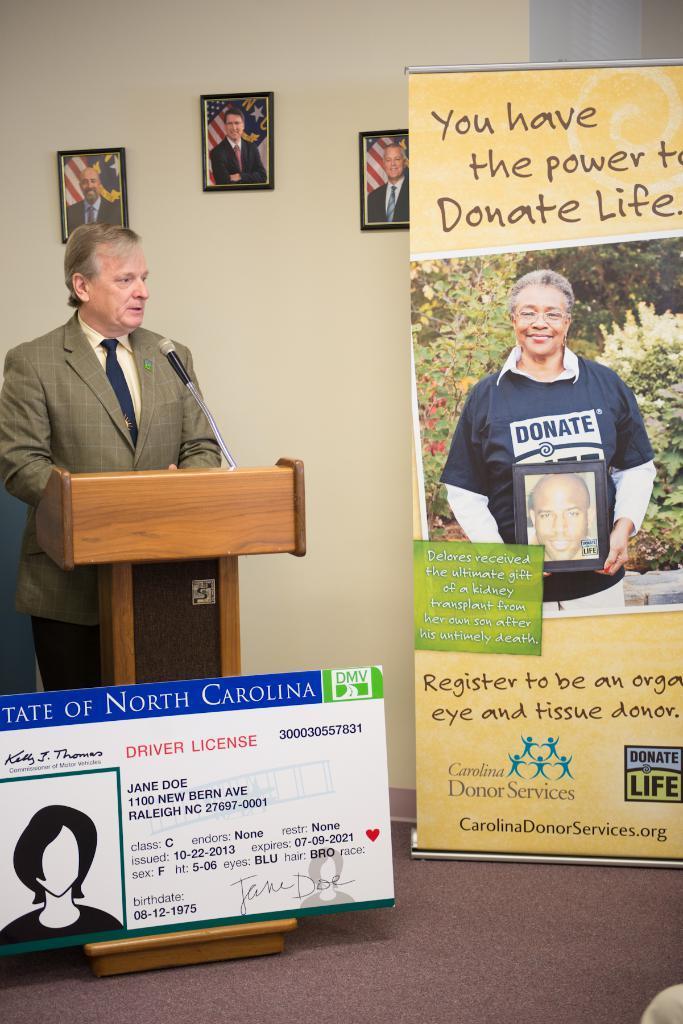Describe this image in one or two sentences. In this image we can see one person standing, wooden table, microphone, some written text on the board, beside that we can see a banner with written text and images, we can see the wall, photo frames. 